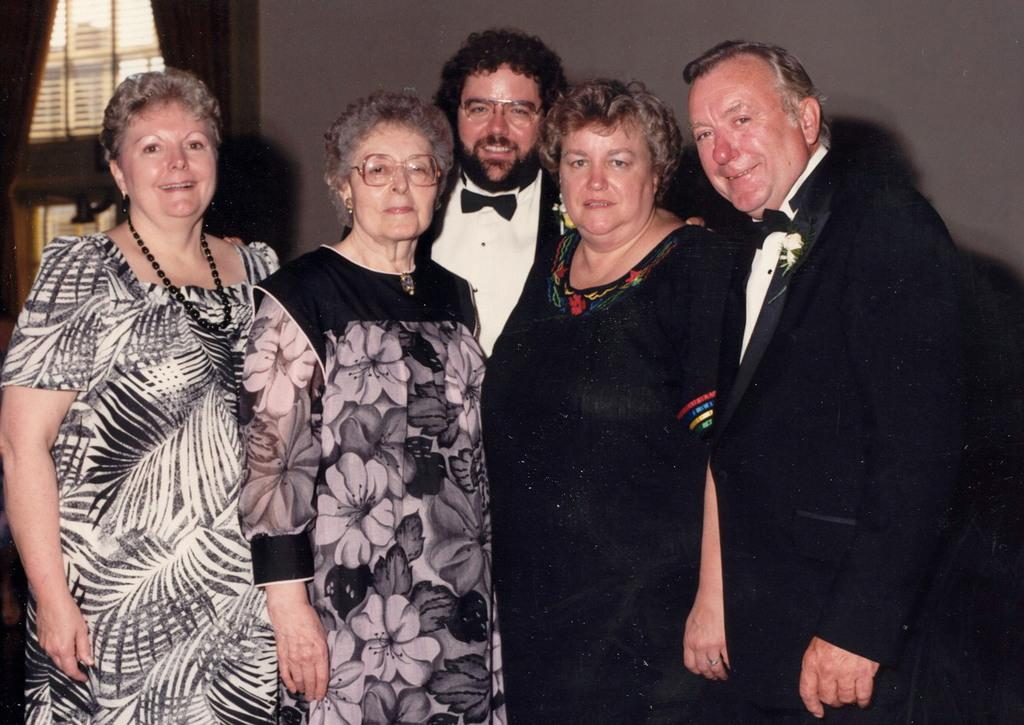How many people are in the image? There is a group of people in the image. What are the people in the image doing? The people are standing and smiling. What can be seen in the background of the image? There is a wall, a window, and curtains associated with the window in the background of the image. What type of kite is being flown by the people in the image? There is no kite present in the image; the people are standing and smiling. What sound can be heard coming from the alarm in the image? There is no alarm present in the image; it features a group of people standing and smiling with a background of a wall, window, and curtains. 